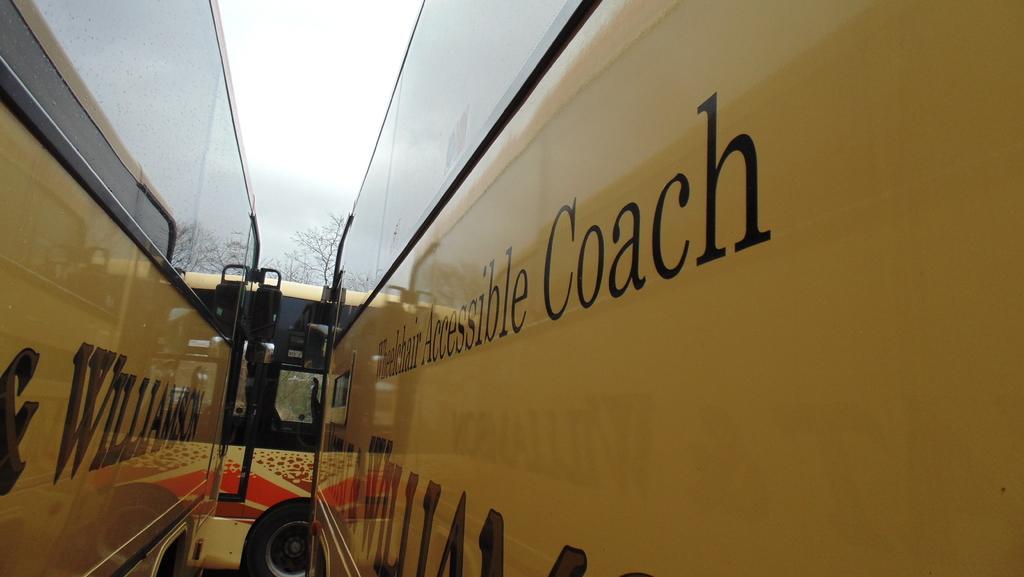Could you give a brief overview of what you see in this image? There are buses presenting in this picture. There is a sky at the top of the image. 